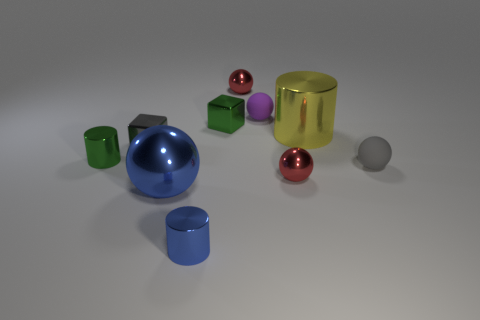Subtract all tiny gray balls. How many balls are left? 4 Subtract all red balls. How many balls are left? 3 Subtract all gray spheres. Subtract all gray blocks. How many spheres are left? 4 Subtract 0 purple cubes. How many objects are left? 10 Subtract all blocks. How many objects are left? 8 Subtract all green shiny blocks. Subtract all big shiny cylinders. How many objects are left? 8 Add 4 small blocks. How many small blocks are left? 6 Add 1 big cyan cubes. How many big cyan cubes exist? 1 